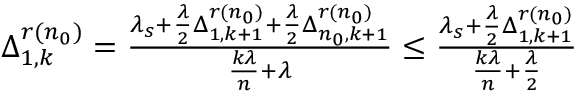<formula> <loc_0><loc_0><loc_500><loc_500>\begin{array} { r } { \, \Delta _ { 1 , k } ^ { r ( n _ { 0 } ) } = \frac { \lambda _ { s } + \frac { \lambda } { 2 } \Delta _ { 1 , k + 1 } ^ { r ( n _ { 0 } ) } + \frac { \lambda } { 2 } \Delta _ { n _ { 0 } , k + 1 } ^ { r ( n _ { 0 } ) } } { \frac { k \lambda } { n } + \lambda } \leq \frac { \lambda _ { s } + \frac { \lambda } { 2 } \Delta _ { 1 , k + 1 } ^ { r ( n _ { 0 } ) } } { \frac { k \lambda } { n } + \frac { \lambda } { 2 } } } \end{array}</formula> 